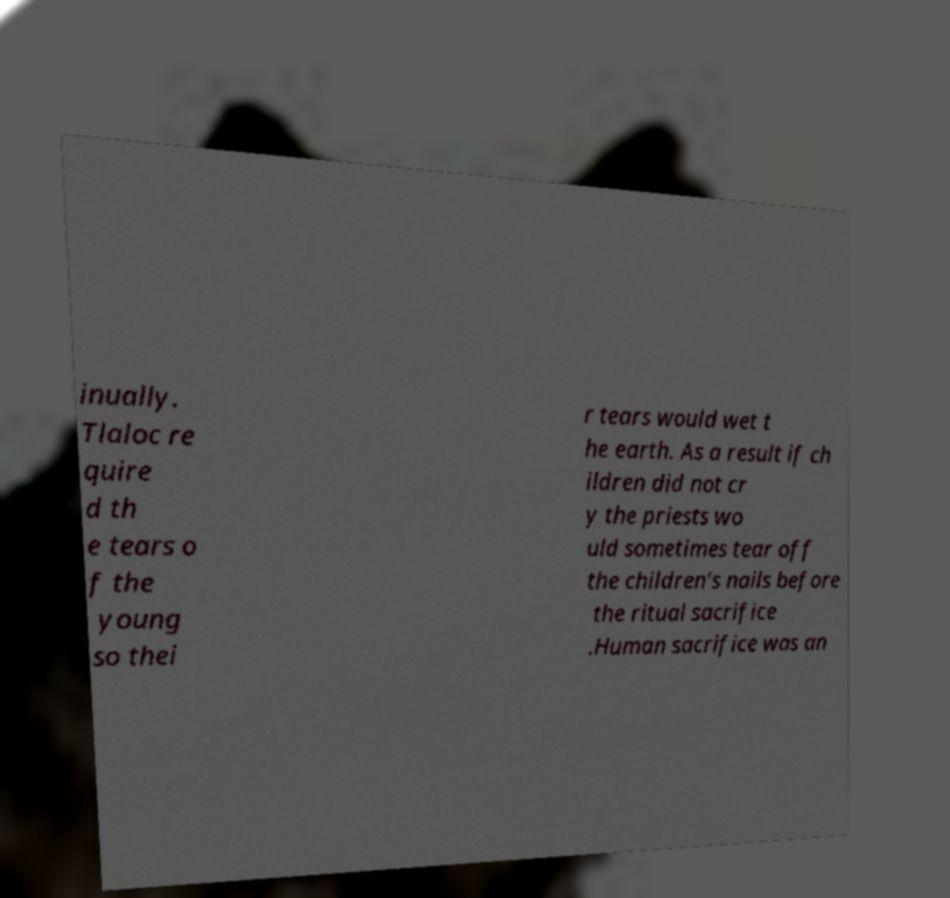Could you assist in decoding the text presented in this image and type it out clearly? inually. Tlaloc re quire d th e tears o f the young so thei r tears would wet t he earth. As a result if ch ildren did not cr y the priests wo uld sometimes tear off the children's nails before the ritual sacrifice .Human sacrifice was an 